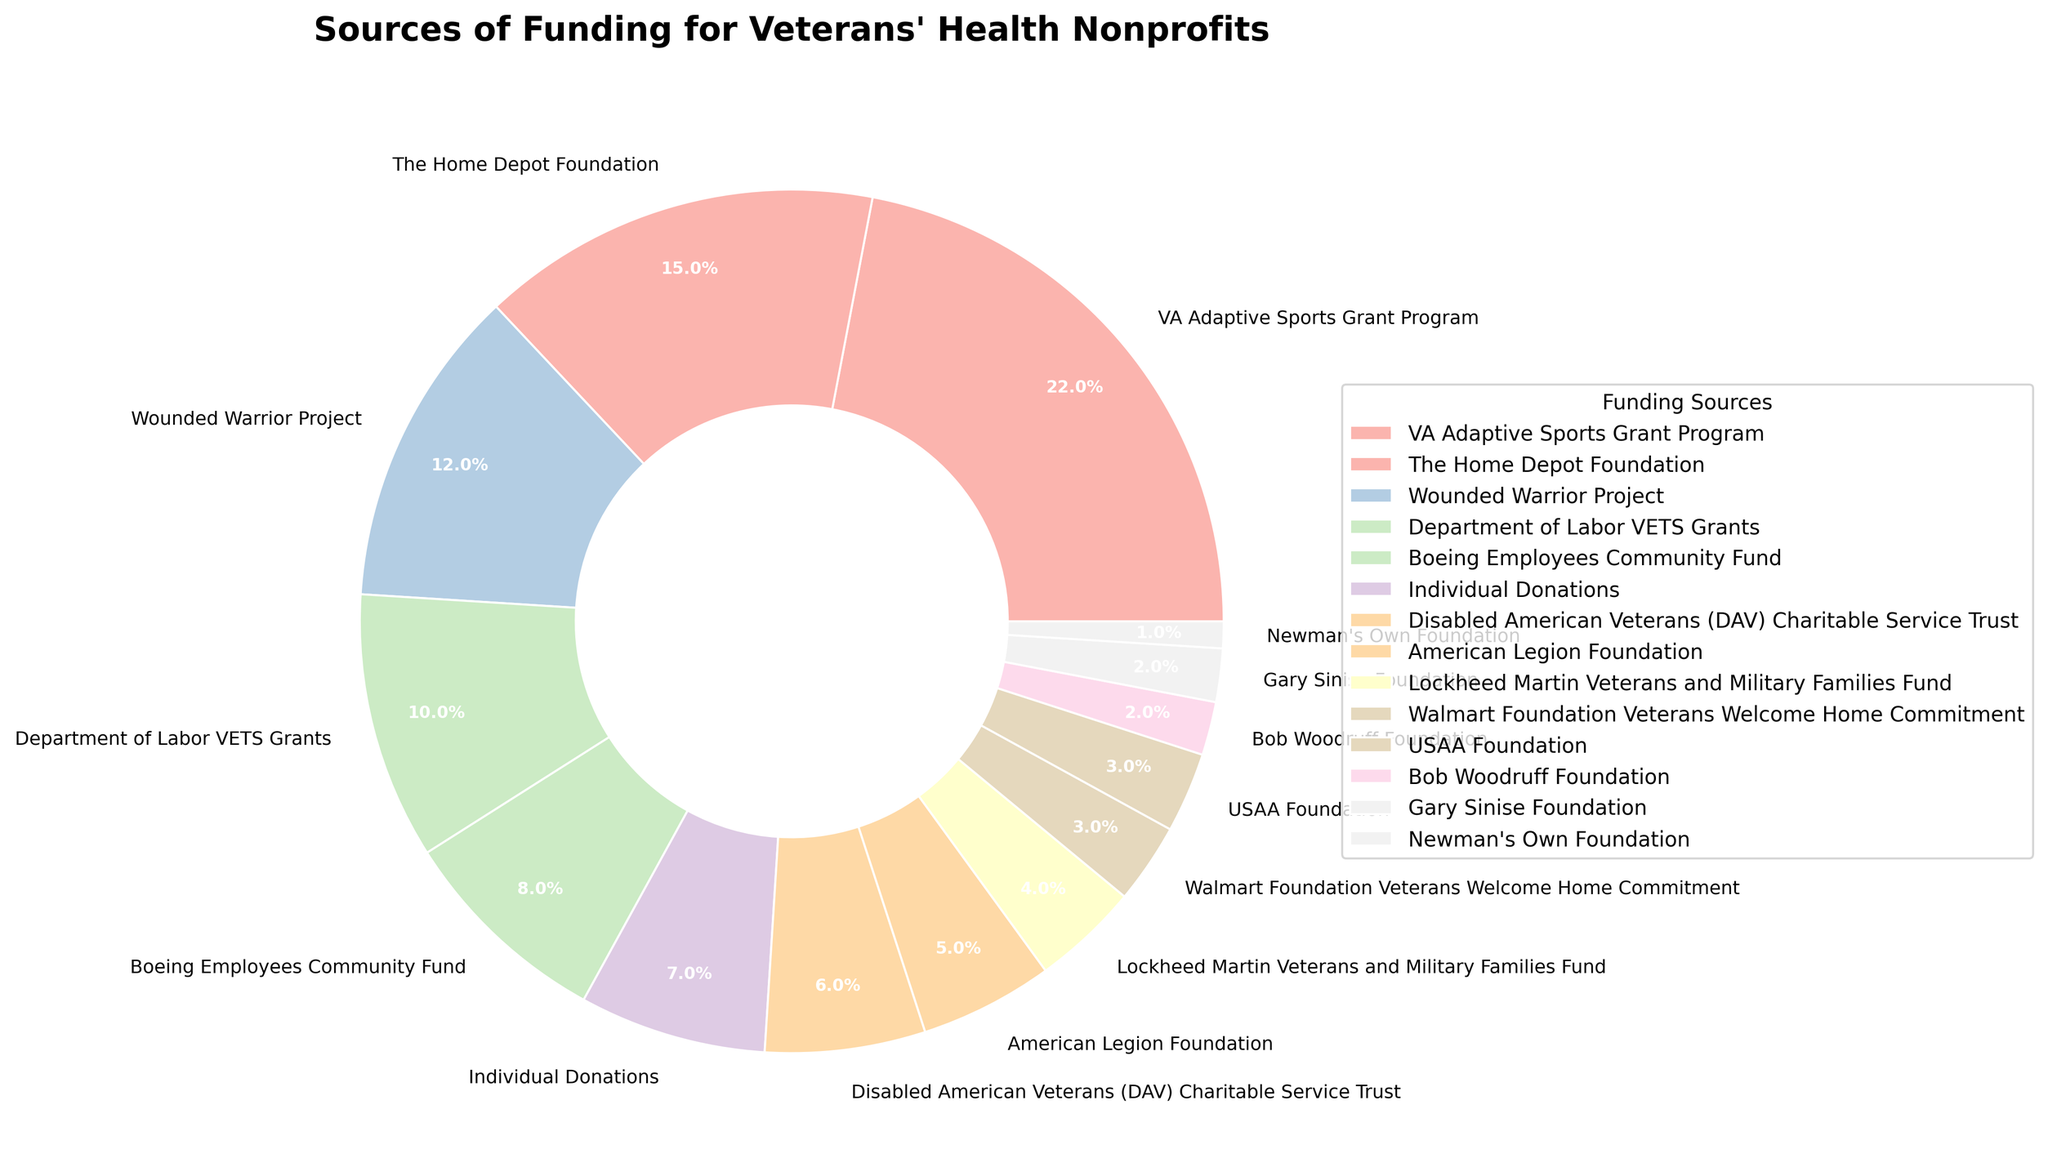Which funding source contributes the highest percentage to veterans' health nonprofits? The largest segment of the pie chart represents the highest percentage of contribution. The "VA Adaptive Sports Grant Program" has the largest segment.
Answer: VA Adaptive Sports Grant Program What is the combined percentage contribution of the Wounded Warrior Project and the Department of Labor VETS Grants? We need to sum the percentages of the Wounded Warrior Project (12%) and the Department of Labor VETS Grants (10%). 12% + 10% = 22%
Answer: 22% Is the combined contribution of individual donations and the Disabled American Veterans (DAV) Charitable Service Trust greater than that of The Home Depot Foundation? Summing up Individual Donations (7%) and DAV Charitable Service Trust (6%) gives us 13%. Comparing 13% to The Home Depot Foundation's 15%, 13% is less than 15%.
Answer: No Which funding source has half the percentage contribution of the VA Adaptive Sports Grant Program? The VA Adaptive Sports Grant Program contributes 22%. Half of 22% is 11%. By looking at the percentages, none of the funding sources contribute exactly 11%, but the Wounded Warrior Project comes close with 12%.
Answer: Wounded Warrior Project What is the percentage difference between the contributions of the Boeing Employees Community Fund and American Legion Foundation? The Boeing Employees Community Fund contributes 8%, and the American Legion Foundation contributes 5%. The difference between them is 8% - 5% = 3%.
Answer: 3% Which funding source contributes the smallest percentage to veterans' health nonprofits? The smallest segment in the pie chart corresponds to the lowest percentage. The Newman's Own Foundation has the smallest segment with 1%.
Answer: Newman's Own Foundation What is the percentage contribution of corporate sponsorships (Boeing Employees Community Fund, Lockheed Martin Veterans and Military Families Fund, and Walmart Foundation Veterans Welcome Home Commitment) combined? Summing up Boeing Employees Community Fund (8%), Lockheed Martin Veterans and Military Families Fund (4%), and Walmart Foundation Veterans Welcome Home Commitment (3%), we get 8% + 4% + 3% = 15%.
Answer: 15% Is the percentage contribution of the USAA Foundation greater than or equal to that of the Gary Sinise Foundation? The USAA Foundation contributes 3%, and the Gary Sinise Foundation contributes 2%. 3% is greater than 2%.
Answer: Yes How many funding sources contribute at least 10% to veterans' health nonprofits? By scanning through the percentages, we see that VA Adaptive Sports Grant Program (22%), The Home Depot Foundation (15%), and Wounded Warrior Project (12%) each contribute at least 10%. Only three funding sources meet this criterion.
Answer: 3 What is the average percentage contribution of the top three funding sources? The top three are VA Adaptive Sports Grant Program (22%), The Home Depot Foundation (15%), and Wounded Warrior Project (12%). The average is (22% + 15% + 12%) / 3 = 49% / 3 = 16.33%.
Answer: 16.33% 